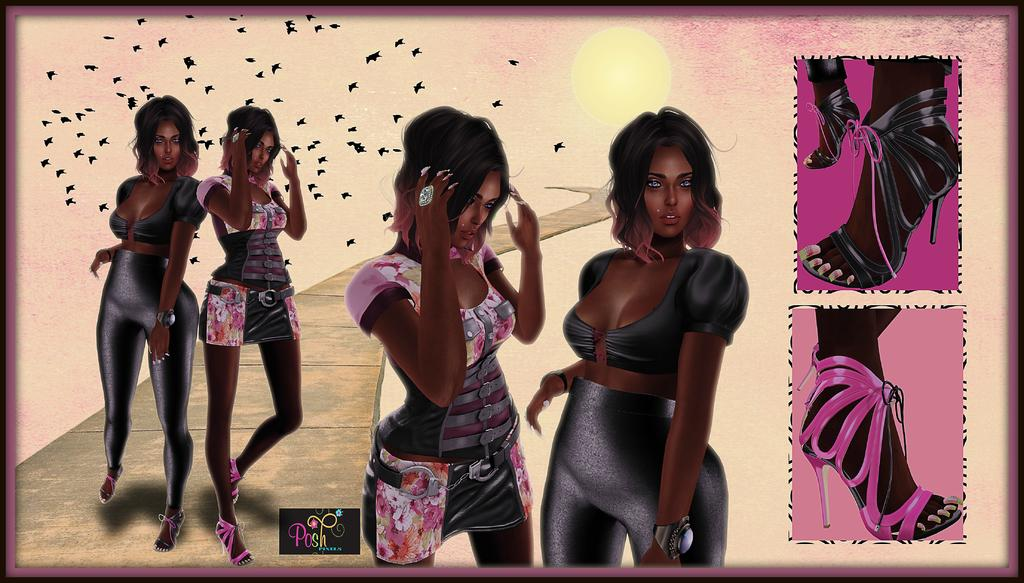What is depicted in the painting in the image? There is a painting of two girls in the image. Where is the painting located in the image? The painting is on the left and middle of the image. What else can be seen in the image besides the painting? There is footwear of girls on the right side of the image. What historical event is depicted in the painting? The painting does not depict a historical event; it is a painting of two girls. Can you see a horse in the image? There is no horse present in the image. 